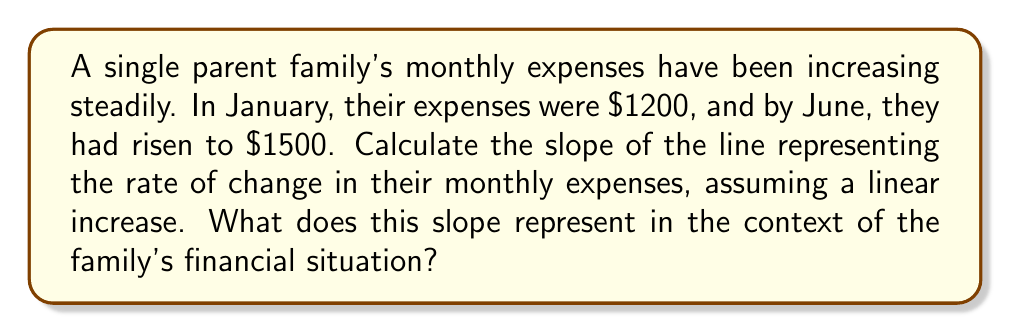Help me with this question. Let's approach this step-by-step:

1) First, we need to identify the points on our line:
   - January (month 1): $(1, 1200)$
   - June (month 6): $(6, 1500)$

2) The slope formula is:
   $$m = \frac{y_2 - y_1}{x_2 - x_1}$$

3) Plugging in our values:
   $$m = \frac{1500 - 1200}{6 - 1} = \frac{300}{5}$$

4) Simplifying:
   $$m = 60$$

5) Interpretation: The slope of 60 represents the rate of change in the family's monthly expenses. It means that, on average, the family's expenses are increasing by $60 per month.

This information could be crucial for a social worker to understand the financial pressures the family is facing and to help develop strategies for budgeting or finding additional resources to support the family.
Answer: $60 per month 